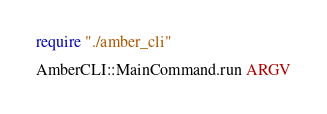<code> <loc_0><loc_0><loc_500><loc_500><_Crystal_>require "./amber_cli"

AmberCLI::MainCommand.run ARGV</code> 